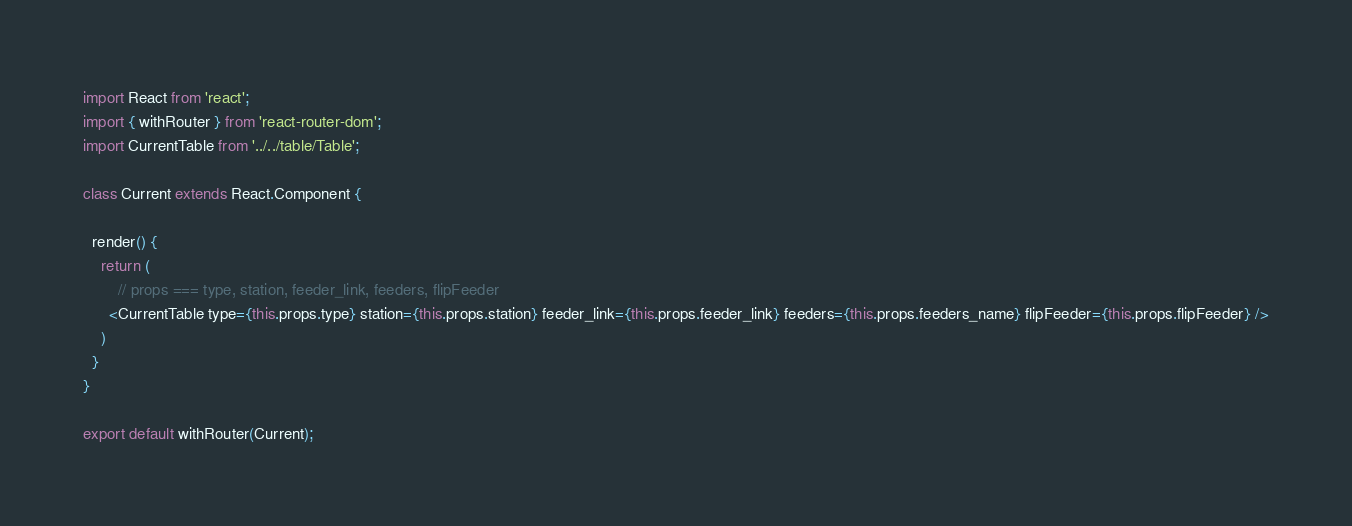<code> <loc_0><loc_0><loc_500><loc_500><_JavaScript_>import React from 'react';
import { withRouter } from 'react-router-dom';
import CurrentTable from '../../table/Table';

class Current extends React.Component {

  render() {    
    return (
        // props === type, station, feeder_link, feeders, flipFeeder
      <CurrentTable type={this.props.type} station={this.props.station} feeder_link={this.props.feeder_link} feeders={this.props.feeders_name} flipFeeder={this.props.flipFeeder} />
    )
  }
}

export default withRouter(Current);
</code> 